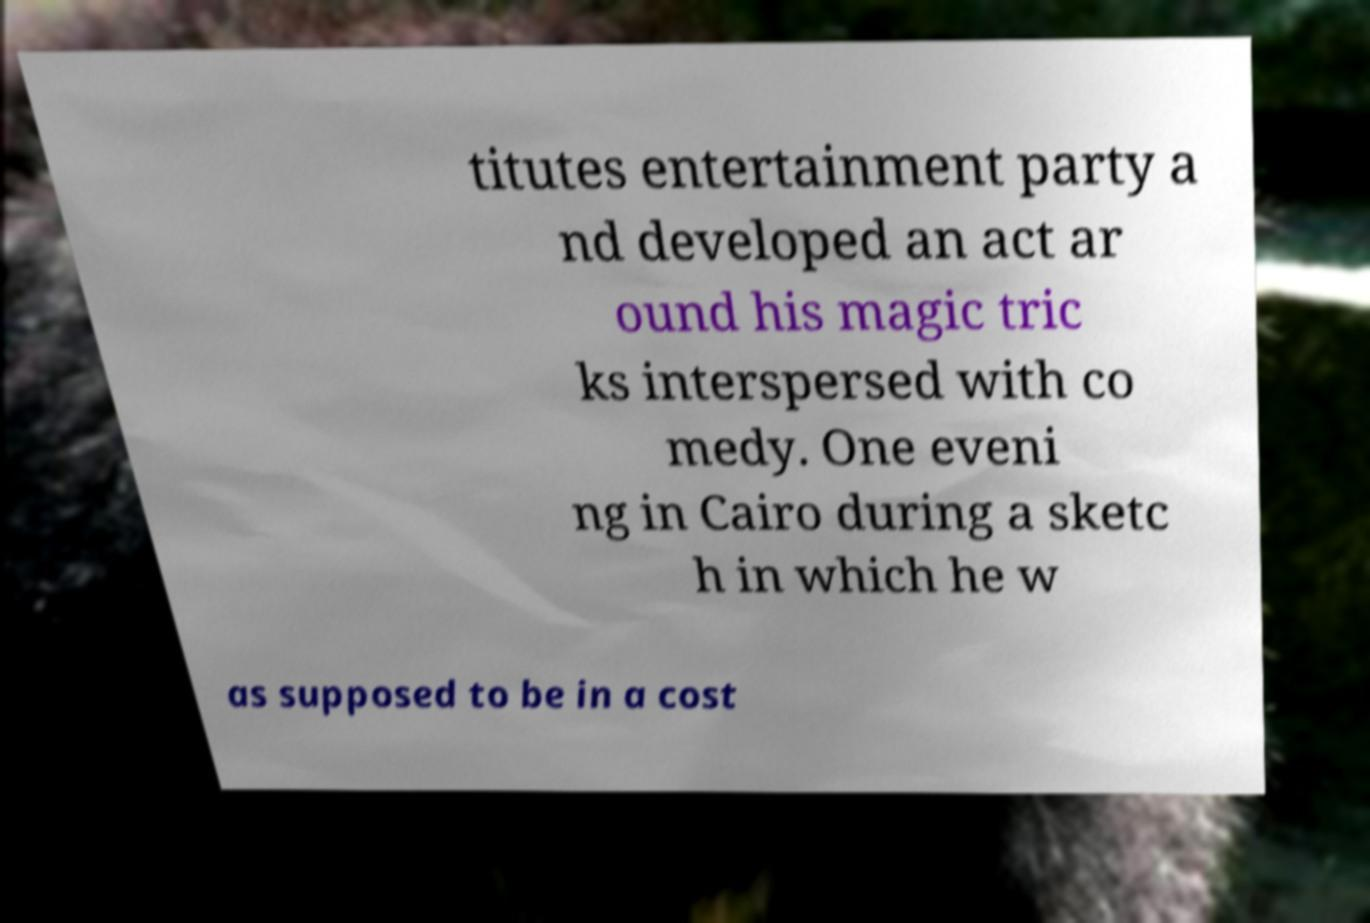What messages or text are displayed in this image? I need them in a readable, typed format. titutes entertainment party a nd developed an act ar ound his magic tric ks interspersed with co medy. One eveni ng in Cairo during a sketc h in which he w as supposed to be in a cost 